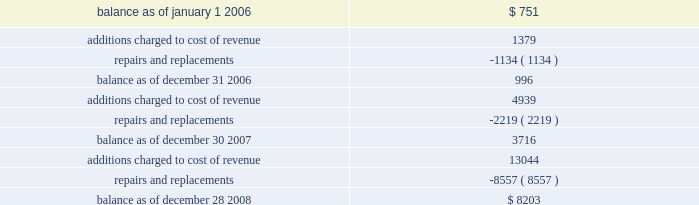Utilized .
In accordance with sfas no .
144 , accounting for the impairment or disposal of long-lived assets , a non-cash impairment charge of $ 4.1 million was recorded in the second quarter of fiscal 2008 for the excess machinery .
This charge is included as a separate line item in the company 2019s consolidated statement of operations .
There was no change to useful lives and related depreciation expense of the remaining assets as the company believes these estimates are currently reflective of the period the assets will be used in operations .
Warranties the company generally provides a one-year warranty on sequencing , genotyping and gene expression systems .
At the time revenue is recognized , the company establishes an accrual for estimated warranty expenses associated with system sales .
This expense is recorded as a component of cost of product revenue .
Estimated warranty expenses associated with extended maintenance contracts are recorded as cost of revenue ratably over the term of the maintenance contract .
Changes in the company 2019s reserve for product warranties from january 1 , 2006 through december 28 , 2008 are as follows ( in thousands ) : .
Convertible senior notes on february 16 , 2007 , the company issued $ 400.0 million principal amount of 0.625% ( 0.625 % ) convertible senior notes due 2014 ( the notes ) , which included the exercise of the initial purchasers 2019 option to purchase up to an additional $ 50.0 million aggregate principal amount of notes .
The net proceeds from the offering , after deducting the initial purchasers 2019 discount and offering expenses , were $ 390.3 million .
The company will pay 0.625% ( 0.625 % ) interest per annum on the principal amount of the notes , payable semi-annually in arrears in cash on february 15 and august 15 of each year .
The company made interest payments of $ 1.3 million and $ 1.2 million on february 15 , 2008 and august 15 , 2008 , respectively .
The notes mature on february 15 , the notes will be convertible into cash and , if applicable , shares of the company 2019s common stock , $ 0.01 par value per share , based on a conversion rate , subject to adjustment , of 45.8058 shares per $ 1000 principal amount of notes ( which represents a conversion price of $ 21.83 per share ) , only in the following circumstances and to the following extent : ( 1 ) during the five business-day period after any five consecutive trading period ( the measurement period ) in which the trading price per note for each day of such measurement period was less than 97% ( 97 % ) of the product of the last reported sale price of the company 2019s common stock and the conversion rate on each such day ; ( 2 ) during any calendar quarter after the calendar quarter ending march 30 , 2007 , if the last reported sale price of the company 2019s common stock for 20 or more trading days in a period of 30 consecutive trading days ending on the last trading day of the immediately illumina , inc .
Notes to consolidated financial statements 2014 ( continued ) .
What was the sum of the interest payments in 2008 in millions .? 
Rationale: the company paid a sum of 2.5 millions in interest in 2008 .
Computations: (1.3 + 1.2)
Answer: 2.5. Utilized .
In accordance with sfas no .
144 , accounting for the impairment or disposal of long-lived assets , a non-cash impairment charge of $ 4.1 million was recorded in the second quarter of fiscal 2008 for the excess machinery .
This charge is included as a separate line item in the company 2019s consolidated statement of operations .
There was no change to useful lives and related depreciation expense of the remaining assets as the company believes these estimates are currently reflective of the period the assets will be used in operations .
Warranties the company generally provides a one-year warranty on sequencing , genotyping and gene expression systems .
At the time revenue is recognized , the company establishes an accrual for estimated warranty expenses associated with system sales .
This expense is recorded as a component of cost of product revenue .
Estimated warranty expenses associated with extended maintenance contracts are recorded as cost of revenue ratably over the term of the maintenance contract .
Changes in the company 2019s reserve for product warranties from january 1 , 2006 through december 28 , 2008 are as follows ( in thousands ) : .
Convertible senior notes on february 16 , 2007 , the company issued $ 400.0 million principal amount of 0.625% ( 0.625 % ) convertible senior notes due 2014 ( the notes ) , which included the exercise of the initial purchasers 2019 option to purchase up to an additional $ 50.0 million aggregate principal amount of notes .
The net proceeds from the offering , after deducting the initial purchasers 2019 discount and offering expenses , were $ 390.3 million .
The company will pay 0.625% ( 0.625 % ) interest per annum on the principal amount of the notes , payable semi-annually in arrears in cash on february 15 and august 15 of each year .
The company made interest payments of $ 1.3 million and $ 1.2 million on february 15 , 2008 and august 15 , 2008 , respectively .
The notes mature on february 15 , the notes will be convertible into cash and , if applicable , shares of the company 2019s common stock , $ 0.01 par value per share , based on a conversion rate , subject to adjustment , of 45.8058 shares per $ 1000 principal amount of notes ( which represents a conversion price of $ 21.83 per share ) , only in the following circumstances and to the following extent : ( 1 ) during the five business-day period after any five consecutive trading period ( the measurement period ) in which the trading price per note for each day of such measurement period was less than 97% ( 97 % ) of the product of the last reported sale price of the company 2019s common stock and the conversion rate on each such day ; ( 2 ) during any calendar quarter after the calendar quarter ending march 30 , 2007 , if the last reported sale price of the company 2019s common stock for 20 or more trading days in a period of 30 consecutive trading days ending on the last trading day of the immediately illumina , inc .
Notes to consolidated financial statements 2014 ( continued ) .
What was the percentage change in the reserve for product warranties from december 30 2007 to december 28 2008? 
Computations: ((8203 - 3716) / 3716)
Answer: 1.20748. 